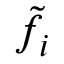Convert formula to latex. <formula><loc_0><loc_0><loc_500><loc_500>\tilde { f } _ { i }</formula> 